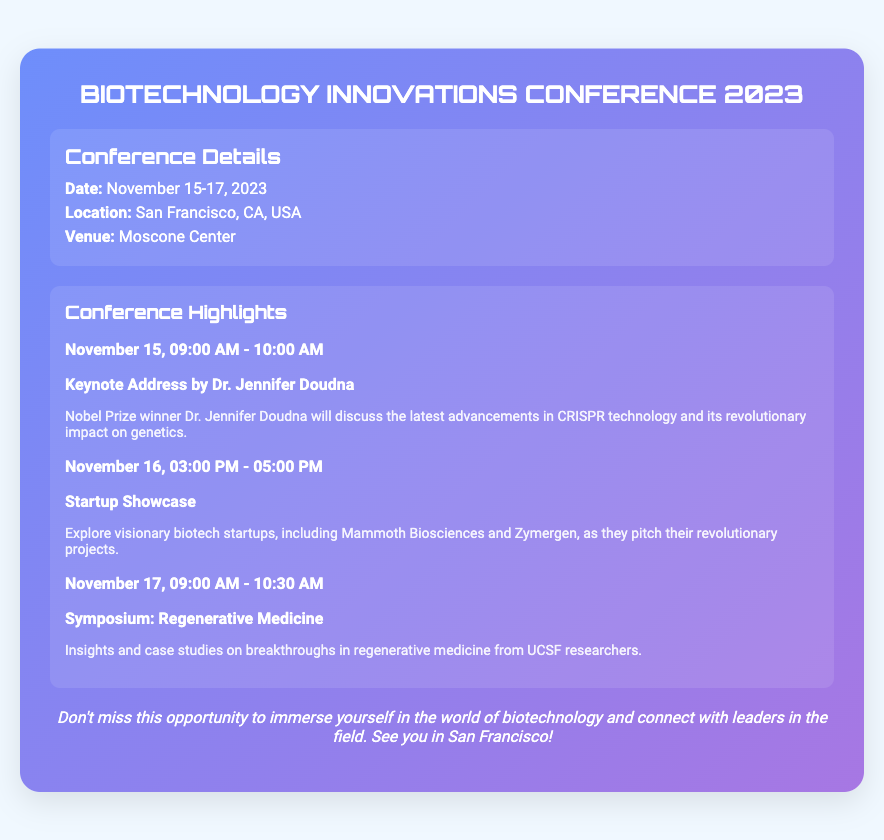What are the dates of the conference? The dates of the conference are specified in the document as November 15-17, 2023.
Answer: November 15-17, 2023 Who is giving the keynote address? The keynote address is given by Nobel Prize winner Dr. Jennifer Doudna, as stated in the document.
Answer: Dr. Jennifer Doudna What is the location of the conference? The location of the conference is mentioned as San Francisco, CA, USA in the document.
Answer: San Francisco, CA, USA What time does the Startup Showcase start? The document states that the Startup Showcase starts at 03:00 PM on November 16.
Answer: 03:00 PM How long is the symposium on regenerative medicine? Based on the schedule, the symposium lasts from 09:00 AM to 10:30 AM on November 17, which is 1.5 hours.
Answer: 1.5 hours What is the venue for the conference? The venue is listed as the Moscone Center in the document.
Answer: Moscone Center What is one of the highlights mentioned for November 15? The highlight mentioned for November 15 is the keynote address by Dr. Jennifer Doudna.
Answer: Keynote Address by Dr. Jennifer Doudna What type of event is happening on November 17? The event on November 17 is a symposium as per the provided schedule.
Answer: Symposium 